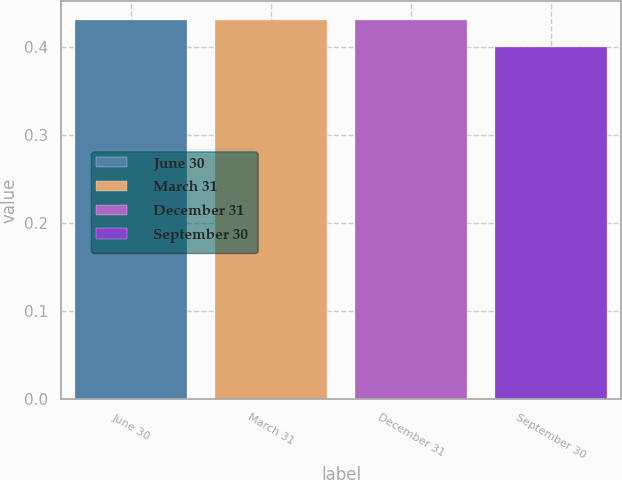<chart> <loc_0><loc_0><loc_500><loc_500><bar_chart><fcel>June 30<fcel>March 31<fcel>December 31<fcel>September 30<nl><fcel>0.43<fcel>0.43<fcel>0.43<fcel>0.4<nl></chart> 